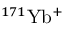Convert formula to latex. <formula><loc_0><loc_0><loc_500><loc_500>{ } ^ { 1 7 1 } Y b ^ { + }</formula> 